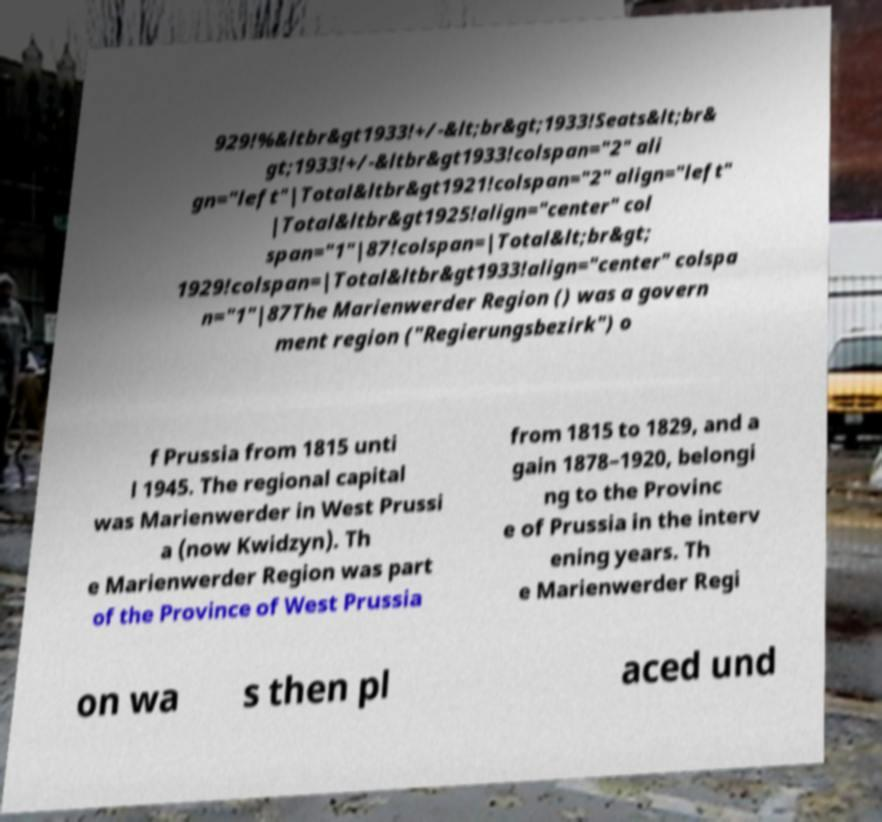There's text embedded in this image that I need extracted. Can you transcribe it verbatim? 929!%&ltbr&gt1933!+/-&lt;br&gt;1933!Seats&lt;br& gt;1933!+/-&ltbr&gt1933!colspan="2" ali gn="left"|Total&ltbr&gt1921!colspan="2" align="left" |Total&ltbr&gt1925!align="center" col span="1"|87!colspan=|Total&lt;br&gt; 1929!colspan=|Total&ltbr&gt1933!align="center" colspa n="1"|87The Marienwerder Region () was a govern ment region ("Regierungsbezirk") o f Prussia from 1815 unti l 1945. The regional capital was Marienwerder in West Prussi a (now Kwidzyn). Th e Marienwerder Region was part of the Province of West Prussia from 1815 to 1829, and a gain 1878–1920, belongi ng to the Provinc e of Prussia in the interv ening years. Th e Marienwerder Regi on wa s then pl aced und 